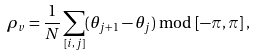<formula> <loc_0><loc_0><loc_500><loc_500>\rho _ { v } = \frac { 1 } { N } \sum _ { [ i , j ] } ( \theta _ { j + 1 } - \theta _ { j } ) \bmod [ - \pi , \, \pi ] \, ,</formula> 